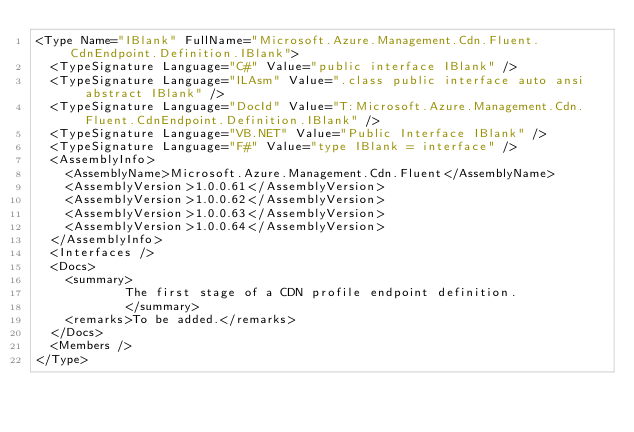<code> <loc_0><loc_0><loc_500><loc_500><_XML_><Type Name="IBlank" FullName="Microsoft.Azure.Management.Cdn.Fluent.CdnEndpoint.Definition.IBlank">
  <TypeSignature Language="C#" Value="public interface IBlank" />
  <TypeSignature Language="ILAsm" Value=".class public interface auto ansi abstract IBlank" />
  <TypeSignature Language="DocId" Value="T:Microsoft.Azure.Management.Cdn.Fluent.CdnEndpoint.Definition.IBlank" />
  <TypeSignature Language="VB.NET" Value="Public Interface IBlank" />
  <TypeSignature Language="F#" Value="type IBlank = interface" />
  <AssemblyInfo>
    <AssemblyName>Microsoft.Azure.Management.Cdn.Fluent</AssemblyName>
    <AssemblyVersion>1.0.0.61</AssemblyVersion>
    <AssemblyVersion>1.0.0.62</AssemblyVersion>
    <AssemblyVersion>1.0.0.63</AssemblyVersion>
    <AssemblyVersion>1.0.0.64</AssemblyVersion>
  </AssemblyInfo>
  <Interfaces />
  <Docs>
    <summary>
            The first stage of a CDN profile endpoint definition.
            </summary>
    <remarks>To be added.</remarks>
  </Docs>
  <Members />
</Type>
</code> 